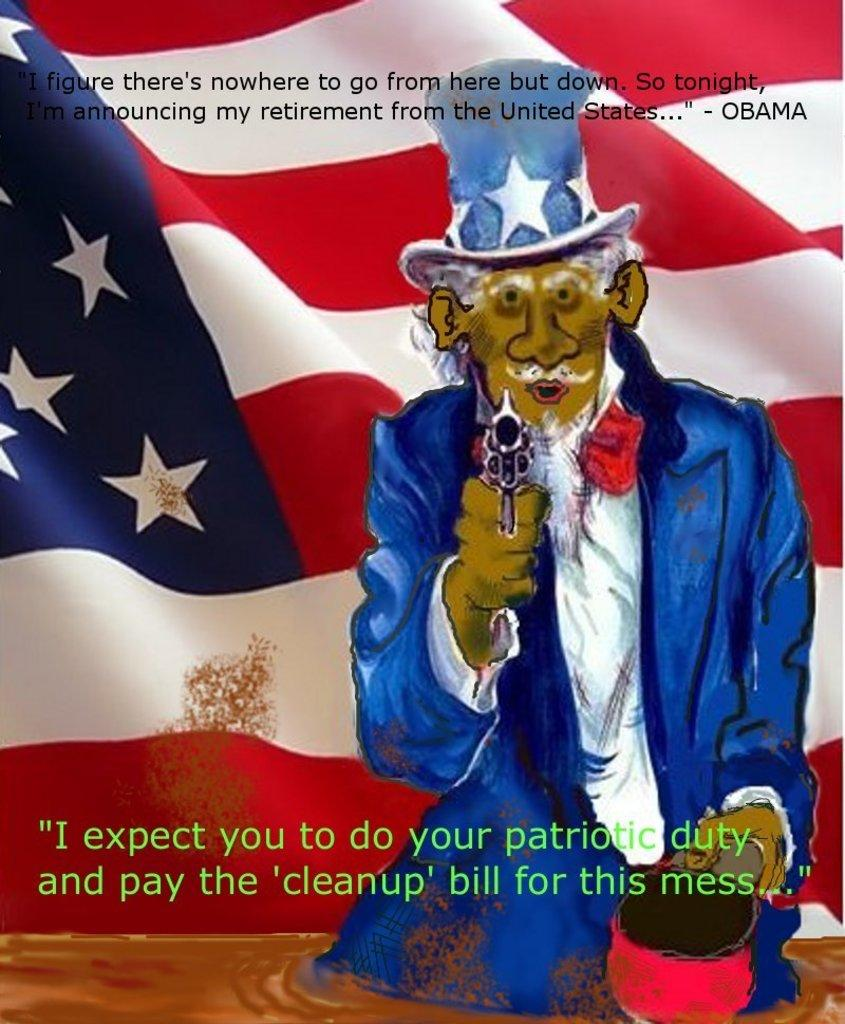What is the main subject of the image? There is a painting in the image. What is depicted in the painting? The painting depicts a man. What is the man wearing in the painting? The man is wearing a blue coat and hat. What is the man holding in the painting? The man is holding a gun. What can be seen in the background of the painting? There is a flag in the background of the painting. Are there any texts present in the painting? Yes, there are texts at the top and bottom of the painting. Can you tell me how wide the river is in the image? There is no river present in the image; it features a painting of a man holding a gun. What type of expansion is shown in the painting? The painting does not depict any expansion; it focuses on the man and his attire, the gun he is holding, and the flag in the background. 